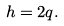Convert formula to latex. <formula><loc_0><loc_0><loc_500><loc_500>h = 2 q .</formula> 